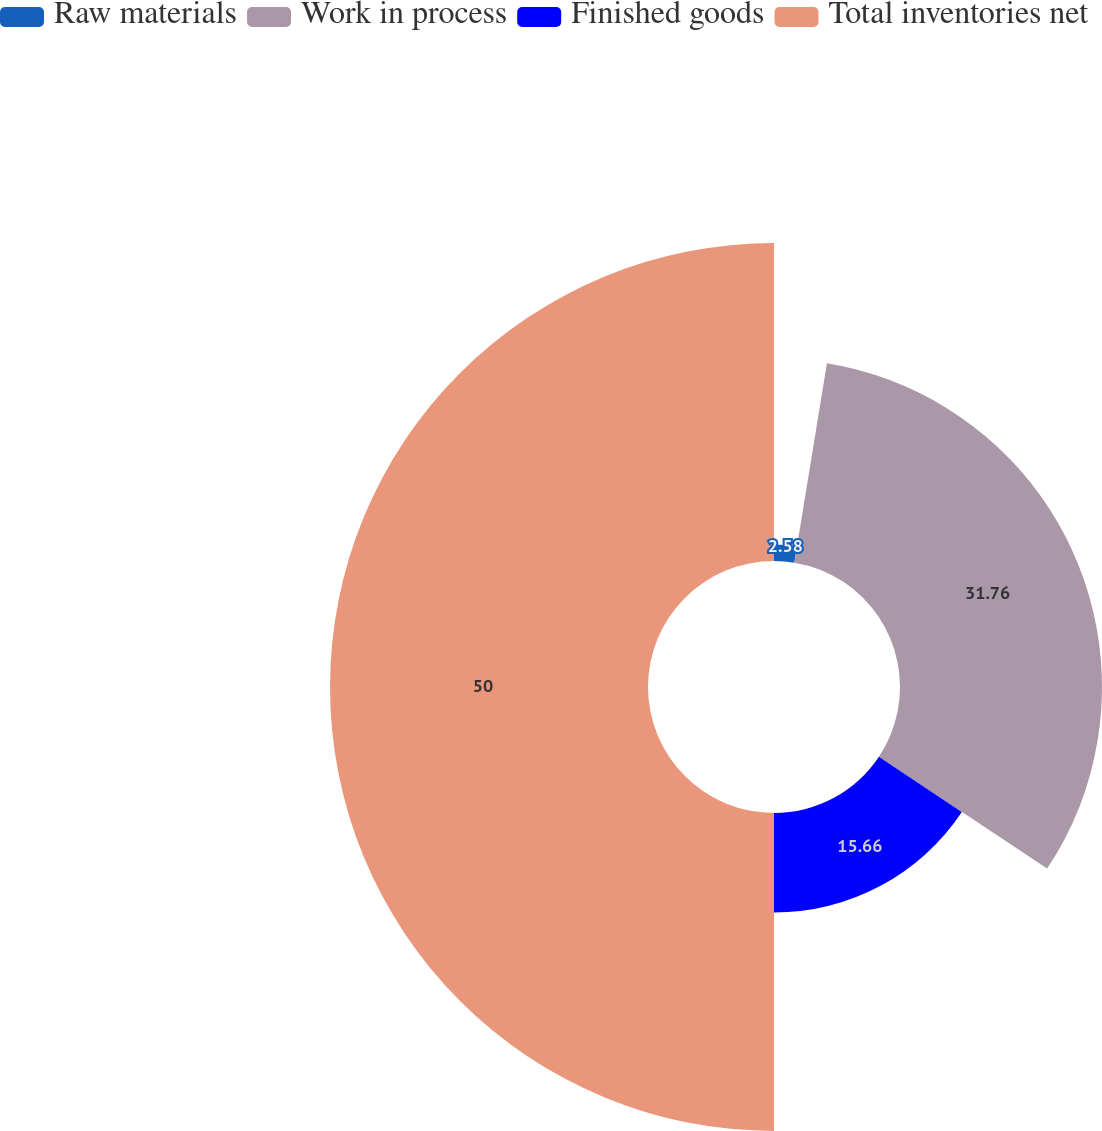Convert chart. <chart><loc_0><loc_0><loc_500><loc_500><pie_chart><fcel>Raw materials<fcel>Work in process<fcel>Finished goods<fcel>Total inventories net<nl><fcel>2.58%<fcel>31.76%<fcel>15.66%<fcel>50.0%<nl></chart> 